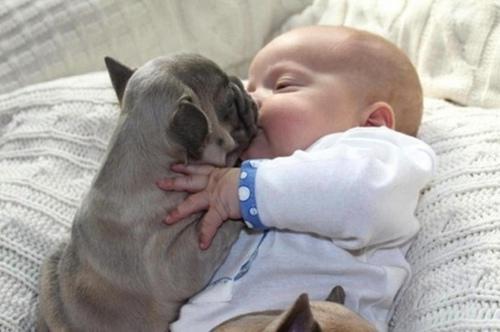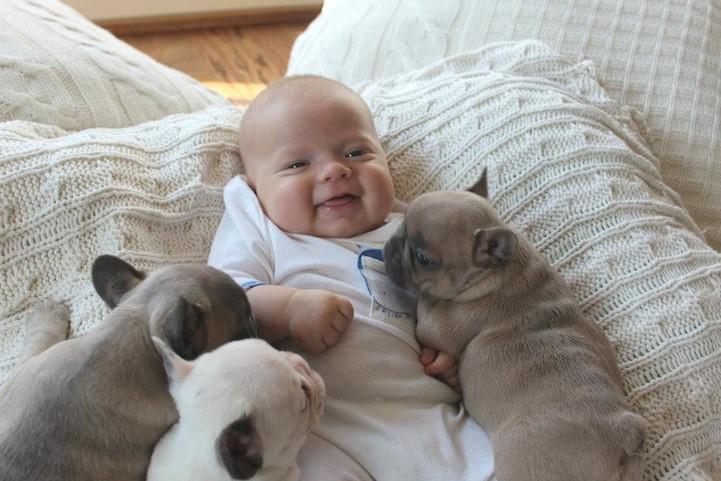The first image is the image on the left, the second image is the image on the right. For the images displayed, is the sentence "The right image contains at least three dogs." factually correct? Answer yes or no. Yes. 